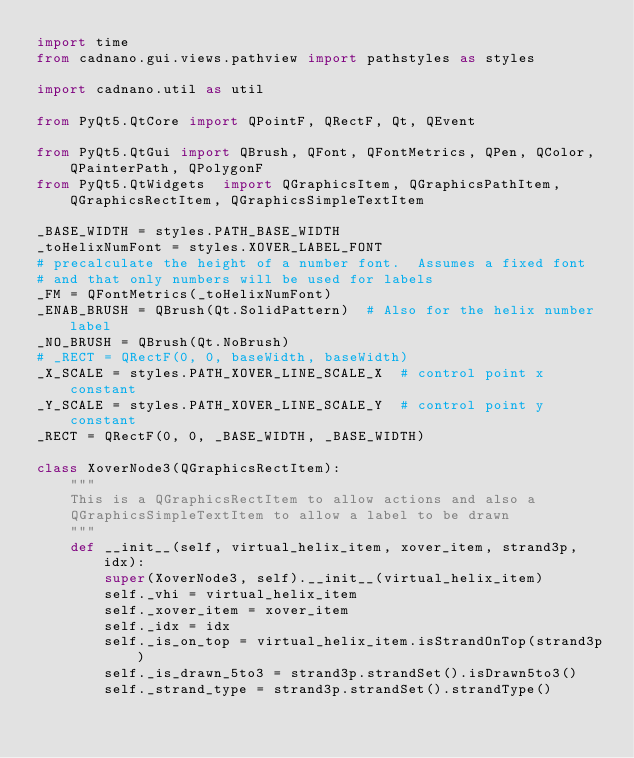Convert code to text. <code><loc_0><loc_0><loc_500><loc_500><_Python_>import time
from cadnano.gui.views.pathview import pathstyles as styles

import cadnano.util as util

from PyQt5.QtCore import QPointF, QRectF, Qt, QEvent

from PyQt5.QtGui import QBrush, QFont, QFontMetrics, QPen, QColor, QPainterPath, QPolygonF
from PyQt5.QtWidgets  import QGraphicsItem, QGraphicsPathItem, QGraphicsRectItem, QGraphicsSimpleTextItem

_BASE_WIDTH = styles.PATH_BASE_WIDTH
_toHelixNumFont = styles.XOVER_LABEL_FONT
# precalculate the height of a number font.  Assumes a fixed font
# and that only numbers will be used for labels
_FM = QFontMetrics(_toHelixNumFont)
_ENAB_BRUSH = QBrush(Qt.SolidPattern)  # Also for the helix number label
_NO_BRUSH = QBrush(Qt.NoBrush)
# _RECT = QRectF(0, 0, baseWidth, baseWidth)
_X_SCALE = styles.PATH_XOVER_LINE_SCALE_X  # control point x constant
_Y_SCALE = styles.PATH_XOVER_LINE_SCALE_Y  # control point y constant
_RECT = QRectF(0, 0, _BASE_WIDTH, _BASE_WIDTH)

class XoverNode3(QGraphicsRectItem):
    """
    This is a QGraphicsRectItem to allow actions and also a 
    QGraphicsSimpleTextItem to allow a label to be drawn
    """
    def __init__(self, virtual_helix_item, xover_item, strand3p, idx):
        super(XoverNode3, self).__init__(virtual_helix_item)
        self._vhi = virtual_helix_item
        self._xover_item = xover_item
        self._idx = idx
        self._is_on_top = virtual_helix_item.isStrandOnTop(strand3p)
        self._is_drawn_5to3 = strand3p.strandSet().isDrawn5to3()
        self._strand_type = strand3p.strandSet().strandType()
</code> 